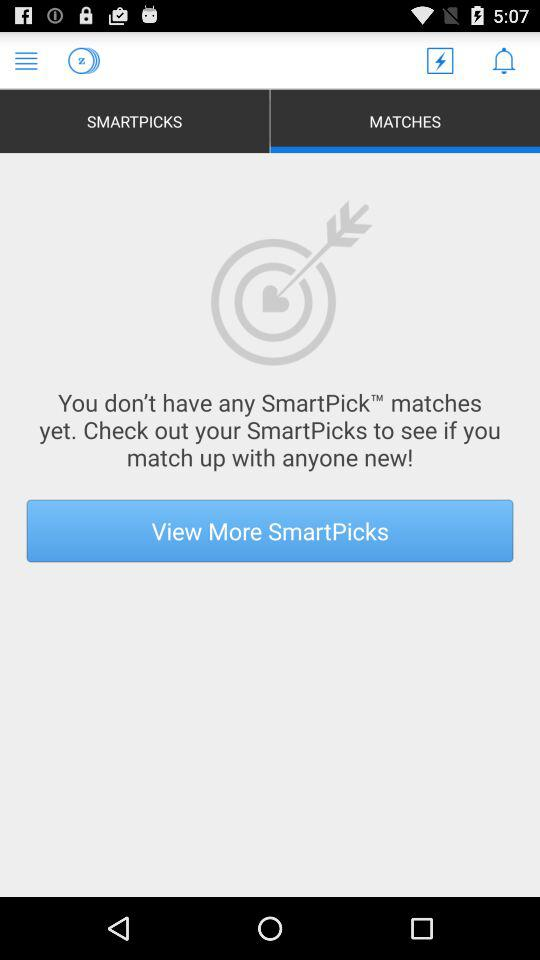Which option has been selected? The selected option is "MATCHES". 